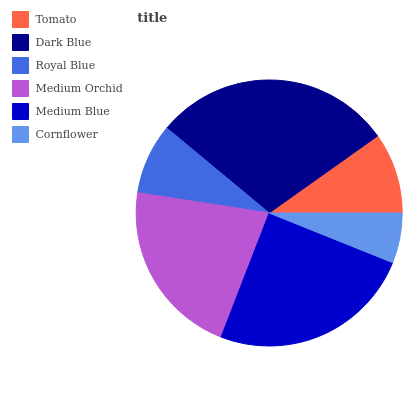Is Cornflower the minimum?
Answer yes or no. Yes. Is Dark Blue the maximum?
Answer yes or no. Yes. Is Royal Blue the minimum?
Answer yes or no. No. Is Royal Blue the maximum?
Answer yes or no. No. Is Dark Blue greater than Royal Blue?
Answer yes or no. Yes. Is Royal Blue less than Dark Blue?
Answer yes or no. Yes. Is Royal Blue greater than Dark Blue?
Answer yes or no. No. Is Dark Blue less than Royal Blue?
Answer yes or no. No. Is Medium Orchid the high median?
Answer yes or no. Yes. Is Tomato the low median?
Answer yes or no. Yes. Is Tomato the high median?
Answer yes or no. No. Is Royal Blue the low median?
Answer yes or no. No. 